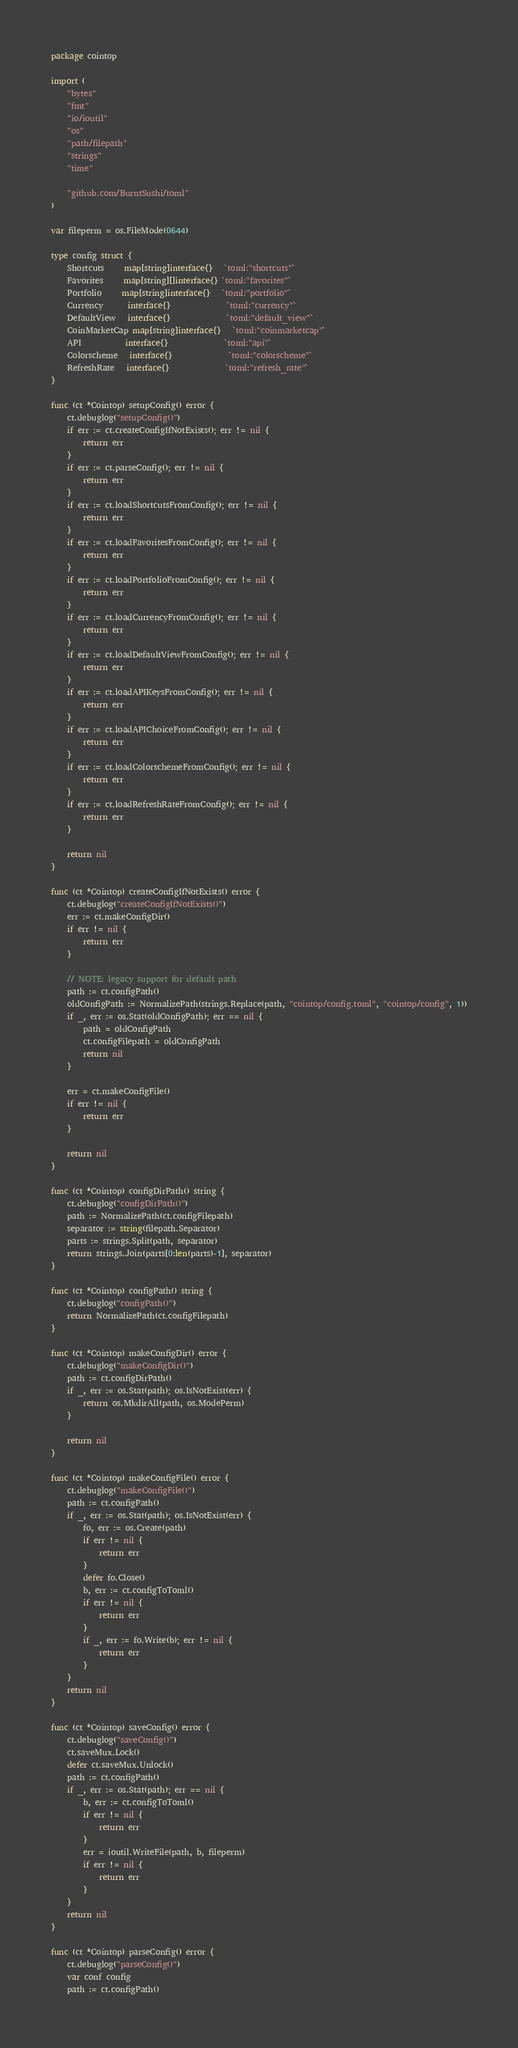Convert code to text. <code><loc_0><loc_0><loc_500><loc_500><_Go_>package cointop

import (
	"bytes"
	"fmt"
	"io/ioutil"
	"os"
	"path/filepath"
	"strings"
	"time"

	"github.com/BurntSushi/toml"
)

var fileperm = os.FileMode(0644)

type config struct {
	Shortcuts     map[string]interface{}   `toml:"shortcuts"`
	Favorites     map[string][]interface{} `toml:"favorites"`
	Portfolio     map[string]interface{}   `toml:"portfolio"`
	Currency      interface{}              `toml:"currency"`
	DefaultView   interface{}              `toml:"default_view"`
	CoinMarketCap map[string]interface{}   `toml:"coinmarketcap"`
	API           interface{}              `toml:"api"`
	Colorscheme   interface{}              `toml:"colorscheme"`
	RefreshRate   interface{}              `toml:"refresh_rate"`
}

func (ct *Cointop) setupConfig() error {
	ct.debuglog("setupConfig()")
	if err := ct.createConfigIfNotExists(); err != nil {
		return err
	}
	if err := ct.parseConfig(); err != nil {
		return err
	}
	if err := ct.loadShortcutsFromConfig(); err != nil {
		return err
	}
	if err := ct.loadFavoritesFromConfig(); err != nil {
		return err
	}
	if err := ct.loadPortfolioFromConfig(); err != nil {
		return err
	}
	if err := ct.loadCurrencyFromConfig(); err != nil {
		return err
	}
	if err := ct.loadDefaultViewFromConfig(); err != nil {
		return err
	}
	if err := ct.loadAPIKeysFromConfig(); err != nil {
		return err
	}
	if err := ct.loadAPIChoiceFromConfig(); err != nil {
		return err
	}
	if err := ct.loadColorschemeFromConfig(); err != nil {
		return err
	}
	if err := ct.loadRefreshRateFromConfig(); err != nil {
		return err
	}

	return nil
}

func (ct *Cointop) createConfigIfNotExists() error {
	ct.debuglog("createConfigIfNotExists()")
	err := ct.makeConfigDir()
	if err != nil {
		return err
	}

	// NOTE: legacy support for default path
	path := ct.configPath()
	oldConfigPath := NormalizePath(strings.Replace(path, "cointop/config.toml", "cointop/config", 1))
	if _, err := os.Stat(oldConfigPath); err == nil {
		path = oldConfigPath
		ct.configFilepath = oldConfigPath
		return nil
	}

	err = ct.makeConfigFile()
	if err != nil {
		return err
	}

	return nil
}

func (ct *Cointop) configDirPath() string {
	ct.debuglog("configDirPath()")
	path := NormalizePath(ct.configFilepath)
	separator := string(filepath.Separator)
	parts := strings.Split(path, separator)
	return strings.Join(parts[0:len(parts)-1], separator)
}

func (ct *Cointop) configPath() string {
	ct.debuglog("configPath()")
	return NormalizePath(ct.configFilepath)
}

func (ct *Cointop) makeConfigDir() error {
	ct.debuglog("makeConfigDir()")
	path := ct.configDirPath()
	if _, err := os.Stat(path); os.IsNotExist(err) {
		return os.MkdirAll(path, os.ModePerm)
	}

	return nil
}

func (ct *Cointop) makeConfigFile() error {
	ct.debuglog("makeConfigFile()")
	path := ct.configPath()
	if _, err := os.Stat(path); os.IsNotExist(err) {
		fo, err := os.Create(path)
		if err != nil {
			return err
		}
		defer fo.Close()
		b, err := ct.configToToml()
		if err != nil {
			return err
		}
		if _, err := fo.Write(b); err != nil {
			return err
		}
	}
	return nil
}

func (ct *Cointop) saveConfig() error {
	ct.debuglog("saveConfig()")
	ct.saveMux.Lock()
	defer ct.saveMux.Unlock()
	path := ct.configPath()
	if _, err := os.Stat(path); err == nil {
		b, err := ct.configToToml()
		if err != nil {
			return err
		}
		err = ioutil.WriteFile(path, b, fileperm)
		if err != nil {
			return err
		}
	}
	return nil
}

func (ct *Cointop) parseConfig() error {
	ct.debuglog("parseConfig()")
	var conf config
	path := ct.configPath()</code> 